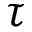Convert formula to latex. <formula><loc_0><loc_0><loc_500><loc_500>\tau</formula> 